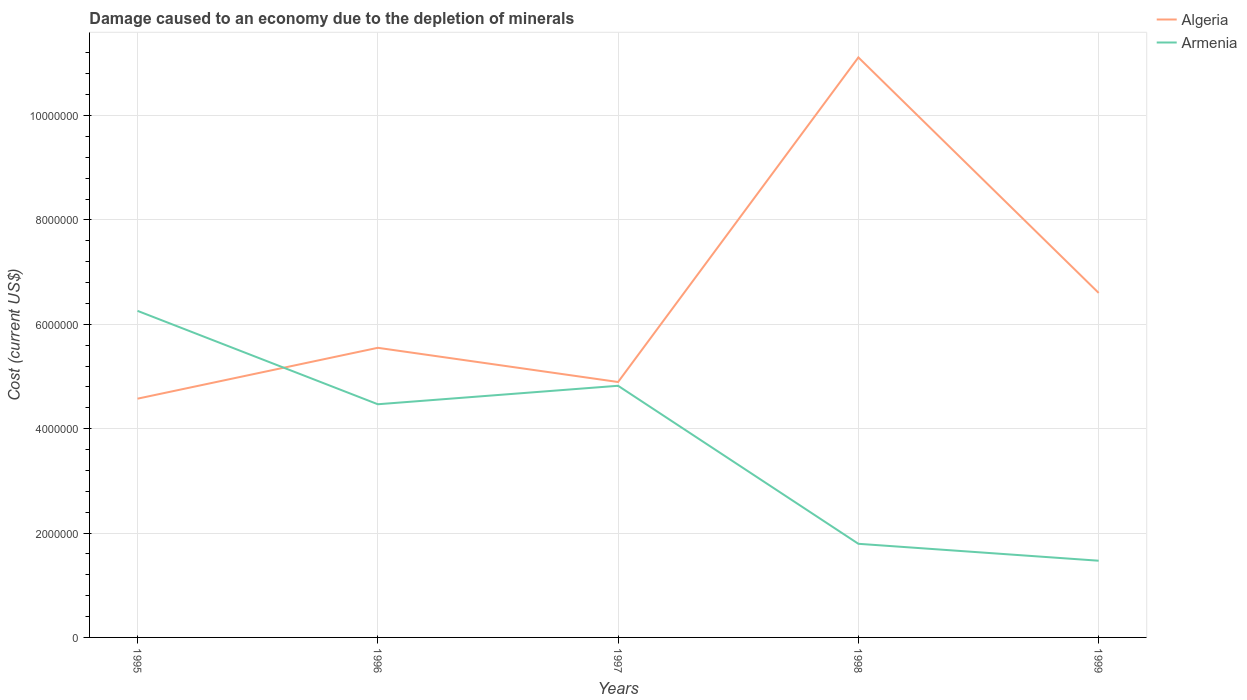Does the line corresponding to Algeria intersect with the line corresponding to Armenia?
Your answer should be compact. Yes. Across all years, what is the maximum cost of damage caused due to the depletion of minerals in Algeria?
Keep it short and to the point. 4.58e+06. What is the total cost of damage caused due to the depletion of minerals in Armenia in the graph?
Provide a short and direct response. 4.46e+06. What is the difference between the highest and the second highest cost of damage caused due to the depletion of minerals in Armenia?
Provide a short and direct response. 4.79e+06. What is the difference between the highest and the lowest cost of damage caused due to the depletion of minerals in Armenia?
Offer a terse response. 3. Is the cost of damage caused due to the depletion of minerals in Armenia strictly greater than the cost of damage caused due to the depletion of minerals in Algeria over the years?
Offer a very short reply. No. How many years are there in the graph?
Ensure brevity in your answer.  5. Does the graph contain grids?
Provide a short and direct response. Yes. How many legend labels are there?
Provide a succinct answer. 2. What is the title of the graph?
Your response must be concise. Damage caused to an economy due to the depletion of minerals. Does "Russian Federation" appear as one of the legend labels in the graph?
Offer a very short reply. No. What is the label or title of the Y-axis?
Your answer should be very brief. Cost (current US$). What is the Cost (current US$) in Algeria in 1995?
Offer a terse response. 4.58e+06. What is the Cost (current US$) in Armenia in 1995?
Your response must be concise. 6.26e+06. What is the Cost (current US$) in Algeria in 1996?
Ensure brevity in your answer.  5.55e+06. What is the Cost (current US$) of Armenia in 1996?
Offer a terse response. 4.47e+06. What is the Cost (current US$) of Algeria in 1997?
Your answer should be very brief. 4.89e+06. What is the Cost (current US$) of Armenia in 1997?
Keep it short and to the point. 4.82e+06. What is the Cost (current US$) in Algeria in 1998?
Offer a terse response. 1.11e+07. What is the Cost (current US$) in Armenia in 1998?
Ensure brevity in your answer.  1.79e+06. What is the Cost (current US$) in Algeria in 1999?
Offer a very short reply. 6.60e+06. What is the Cost (current US$) of Armenia in 1999?
Offer a very short reply. 1.47e+06. Across all years, what is the maximum Cost (current US$) of Algeria?
Your response must be concise. 1.11e+07. Across all years, what is the maximum Cost (current US$) in Armenia?
Give a very brief answer. 6.26e+06. Across all years, what is the minimum Cost (current US$) in Algeria?
Ensure brevity in your answer.  4.58e+06. Across all years, what is the minimum Cost (current US$) of Armenia?
Provide a short and direct response. 1.47e+06. What is the total Cost (current US$) of Algeria in the graph?
Offer a very short reply. 3.27e+07. What is the total Cost (current US$) of Armenia in the graph?
Your answer should be very brief. 1.88e+07. What is the difference between the Cost (current US$) in Algeria in 1995 and that in 1996?
Offer a terse response. -9.75e+05. What is the difference between the Cost (current US$) of Armenia in 1995 and that in 1996?
Your answer should be compact. 1.79e+06. What is the difference between the Cost (current US$) in Algeria in 1995 and that in 1997?
Keep it short and to the point. -3.20e+05. What is the difference between the Cost (current US$) in Armenia in 1995 and that in 1997?
Provide a short and direct response. 1.44e+06. What is the difference between the Cost (current US$) of Algeria in 1995 and that in 1998?
Your response must be concise. -6.54e+06. What is the difference between the Cost (current US$) in Armenia in 1995 and that in 1998?
Provide a short and direct response. 4.46e+06. What is the difference between the Cost (current US$) in Algeria in 1995 and that in 1999?
Give a very brief answer. -2.03e+06. What is the difference between the Cost (current US$) of Armenia in 1995 and that in 1999?
Your answer should be compact. 4.79e+06. What is the difference between the Cost (current US$) in Algeria in 1996 and that in 1997?
Provide a succinct answer. 6.55e+05. What is the difference between the Cost (current US$) in Armenia in 1996 and that in 1997?
Provide a succinct answer. -3.54e+05. What is the difference between the Cost (current US$) in Algeria in 1996 and that in 1998?
Make the answer very short. -5.56e+06. What is the difference between the Cost (current US$) in Armenia in 1996 and that in 1998?
Your response must be concise. 2.67e+06. What is the difference between the Cost (current US$) in Algeria in 1996 and that in 1999?
Make the answer very short. -1.05e+06. What is the difference between the Cost (current US$) of Armenia in 1996 and that in 1999?
Provide a succinct answer. 3.00e+06. What is the difference between the Cost (current US$) of Algeria in 1997 and that in 1998?
Give a very brief answer. -6.22e+06. What is the difference between the Cost (current US$) in Armenia in 1997 and that in 1998?
Your answer should be compact. 3.03e+06. What is the difference between the Cost (current US$) in Algeria in 1997 and that in 1999?
Make the answer very short. -1.71e+06. What is the difference between the Cost (current US$) of Armenia in 1997 and that in 1999?
Offer a very short reply. 3.35e+06. What is the difference between the Cost (current US$) of Algeria in 1998 and that in 1999?
Your answer should be compact. 4.51e+06. What is the difference between the Cost (current US$) in Armenia in 1998 and that in 1999?
Your answer should be very brief. 3.24e+05. What is the difference between the Cost (current US$) of Algeria in 1995 and the Cost (current US$) of Armenia in 1996?
Keep it short and to the point. 1.07e+05. What is the difference between the Cost (current US$) of Algeria in 1995 and the Cost (current US$) of Armenia in 1997?
Offer a very short reply. -2.47e+05. What is the difference between the Cost (current US$) of Algeria in 1995 and the Cost (current US$) of Armenia in 1998?
Provide a succinct answer. 2.78e+06. What is the difference between the Cost (current US$) of Algeria in 1995 and the Cost (current US$) of Armenia in 1999?
Your answer should be compact. 3.11e+06. What is the difference between the Cost (current US$) of Algeria in 1996 and the Cost (current US$) of Armenia in 1997?
Your answer should be compact. 7.27e+05. What is the difference between the Cost (current US$) in Algeria in 1996 and the Cost (current US$) in Armenia in 1998?
Keep it short and to the point. 3.76e+06. What is the difference between the Cost (current US$) of Algeria in 1996 and the Cost (current US$) of Armenia in 1999?
Offer a very short reply. 4.08e+06. What is the difference between the Cost (current US$) of Algeria in 1997 and the Cost (current US$) of Armenia in 1998?
Provide a short and direct response. 3.10e+06. What is the difference between the Cost (current US$) in Algeria in 1997 and the Cost (current US$) in Armenia in 1999?
Your response must be concise. 3.42e+06. What is the difference between the Cost (current US$) of Algeria in 1998 and the Cost (current US$) of Armenia in 1999?
Offer a terse response. 9.64e+06. What is the average Cost (current US$) of Algeria per year?
Make the answer very short. 6.55e+06. What is the average Cost (current US$) in Armenia per year?
Keep it short and to the point. 3.76e+06. In the year 1995, what is the difference between the Cost (current US$) of Algeria and Cost (current US$) of Armenia?
Your answer should be very brief. -1.68e+06. In the year 1996, what is the difference between the Cost (current US$) in Algeria and Cost (current US$) in Armenia?
Make the answer very short. 1.08e+06. In the year 1997, what is the difference between the Cost (current US$) in Algeria and Cost (current US$) in Armenia?
Provide a succinct answer. 7.21e+04. In the year 1998, what is the difference between the Cost (current US$) of Algeria and Cost (current US$) of Armenia?
Your answer should be very brief. 9.32e+06. In the year 1999, what is the difference between the Cost (current US$) of Algeria and Cost (current US$) of Armenia?
Keep it short and to the point. 5.13e+06. What is the ratio of the Cost (current US$) of Algeria in 1995 to that in 1996?
Offer a terse response. 0.82. What is the ratio of the Cost (current US$) of Armenia in 1995 to that in 1996?
Your answer should be very brief. 1.4. What is the ratio of the Cost (current US$) in Algeria in 1995 to that in 1997?
Ensure brevity in your answer.  0.93. What is the ratio of the Cost (current US$) in Armenia in 1995 to that in 1997?
Make the answer very short. 1.3. What is the ratio of the Cost (current US$) in Algeria in 1995 to that in 1998?
Provide a succinct answer. 0.41. What is the ratio of the Cost (current US$) of Armenia in 1995 to that in 1998?
Offer a very short reply. 3.49. What is the ratio of the Cost (current US$) of Algeria in 1995 to that in 1999?
Your answer should be compact. 0.69. What is the ratio of the Cost (current US$) in Armenia in 1995 to that in 1999?
Your response must be concise. 4.26. What is the ratio of the Cost (current US$) in Algeria in 1996 to that in 1997?
Make the answer very short. 1.13. What is the ratio of the Cost (current US$) of Armenia in 1996 to that in 1997?
Offer a very short reply. 0.93. What is the ratio of the Cost (current US$) in Algeria in 1996 to that in 1998?
Give a very brief answer. 0.5. What is the ratio of the Cost (current US$) in Armenia in 1996 to that in 1998?
Make the answer very short. 2.49. What is the ratio of the Cost (current US$) of Algeria in 1996 to that in 1999?
Make the answer very short. 0.84. What is the ratio of the Cost (current US$) of Armenia in 1996 to that in 1999?
Provide a short and direct response. 3.04. What is the ratio of the Cost (current US$) in Algeria in 1997 to that in 1998?
Give a very brief answer. 0.44. What is the ratio of the Cost (current US$) in Armenia in 1997 to that in 1998?
Ensure brevity in your answer.  2.69. What is the ratio of the Cost (current US$) in Algeria in 1997 to that in 1999?
Give a very brief answer. 0.74. What is the ratio of the Cost (current US$) in Armenia in 1997 to that in 1999?
Ensure brevity in your answer.  3.28. What is the ratio of the Cost (current US$) in Algeria in 1998 to that in 1999?
Offer a terse response. 1.68. What is the ratio of the Cost (current US$) in Armenia in 1998 to that in 1999?
Offer a terse response. 1.22. What is the difference between the highest and the second highest Cost (current US$) of Algeria?
Your response must be concise. 4.51e+06. What is the difference between the highest and the second highest Cost (current US$) in Armenia?
Ensure brevity in your answer.  1.44e+06. What is the difference between the highest and the lowest Cost (current US$) of Algeria?
Make the answer very short. 6.54e+06. What is the difference between the highest and the lowest Cost (current US$) of Armenia?
Provide a short and direct response. 4.79e+06. 